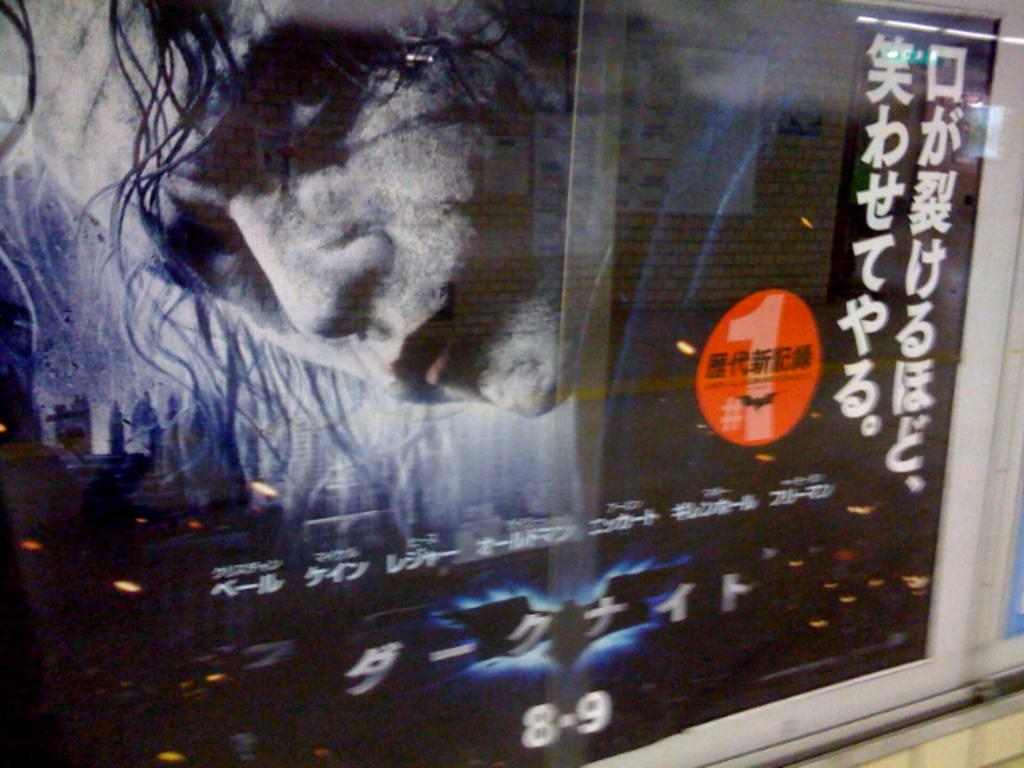Provide a one-sentence caption for the provided image. A poster showing the Joker in Batman the movie. 